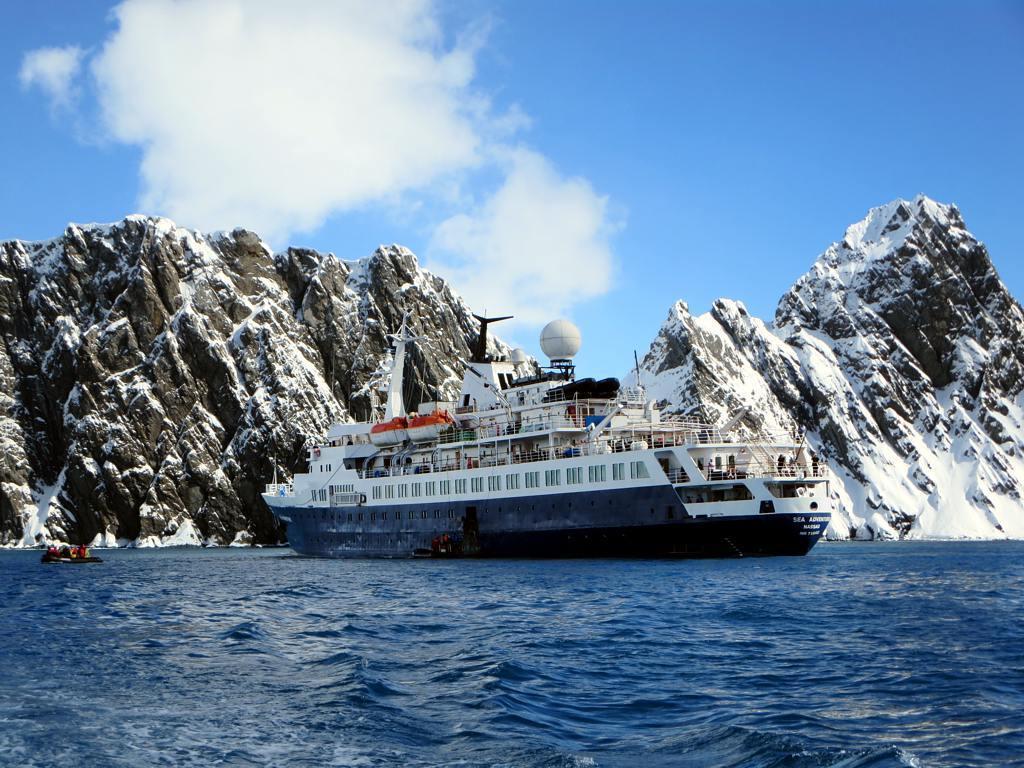How would you summarize this image in a sentence or two? At the bottom of the image there is water, above the water there is ship. Behind the ship there are some hills and snow. At the top of the image there are some clouds and sky. 